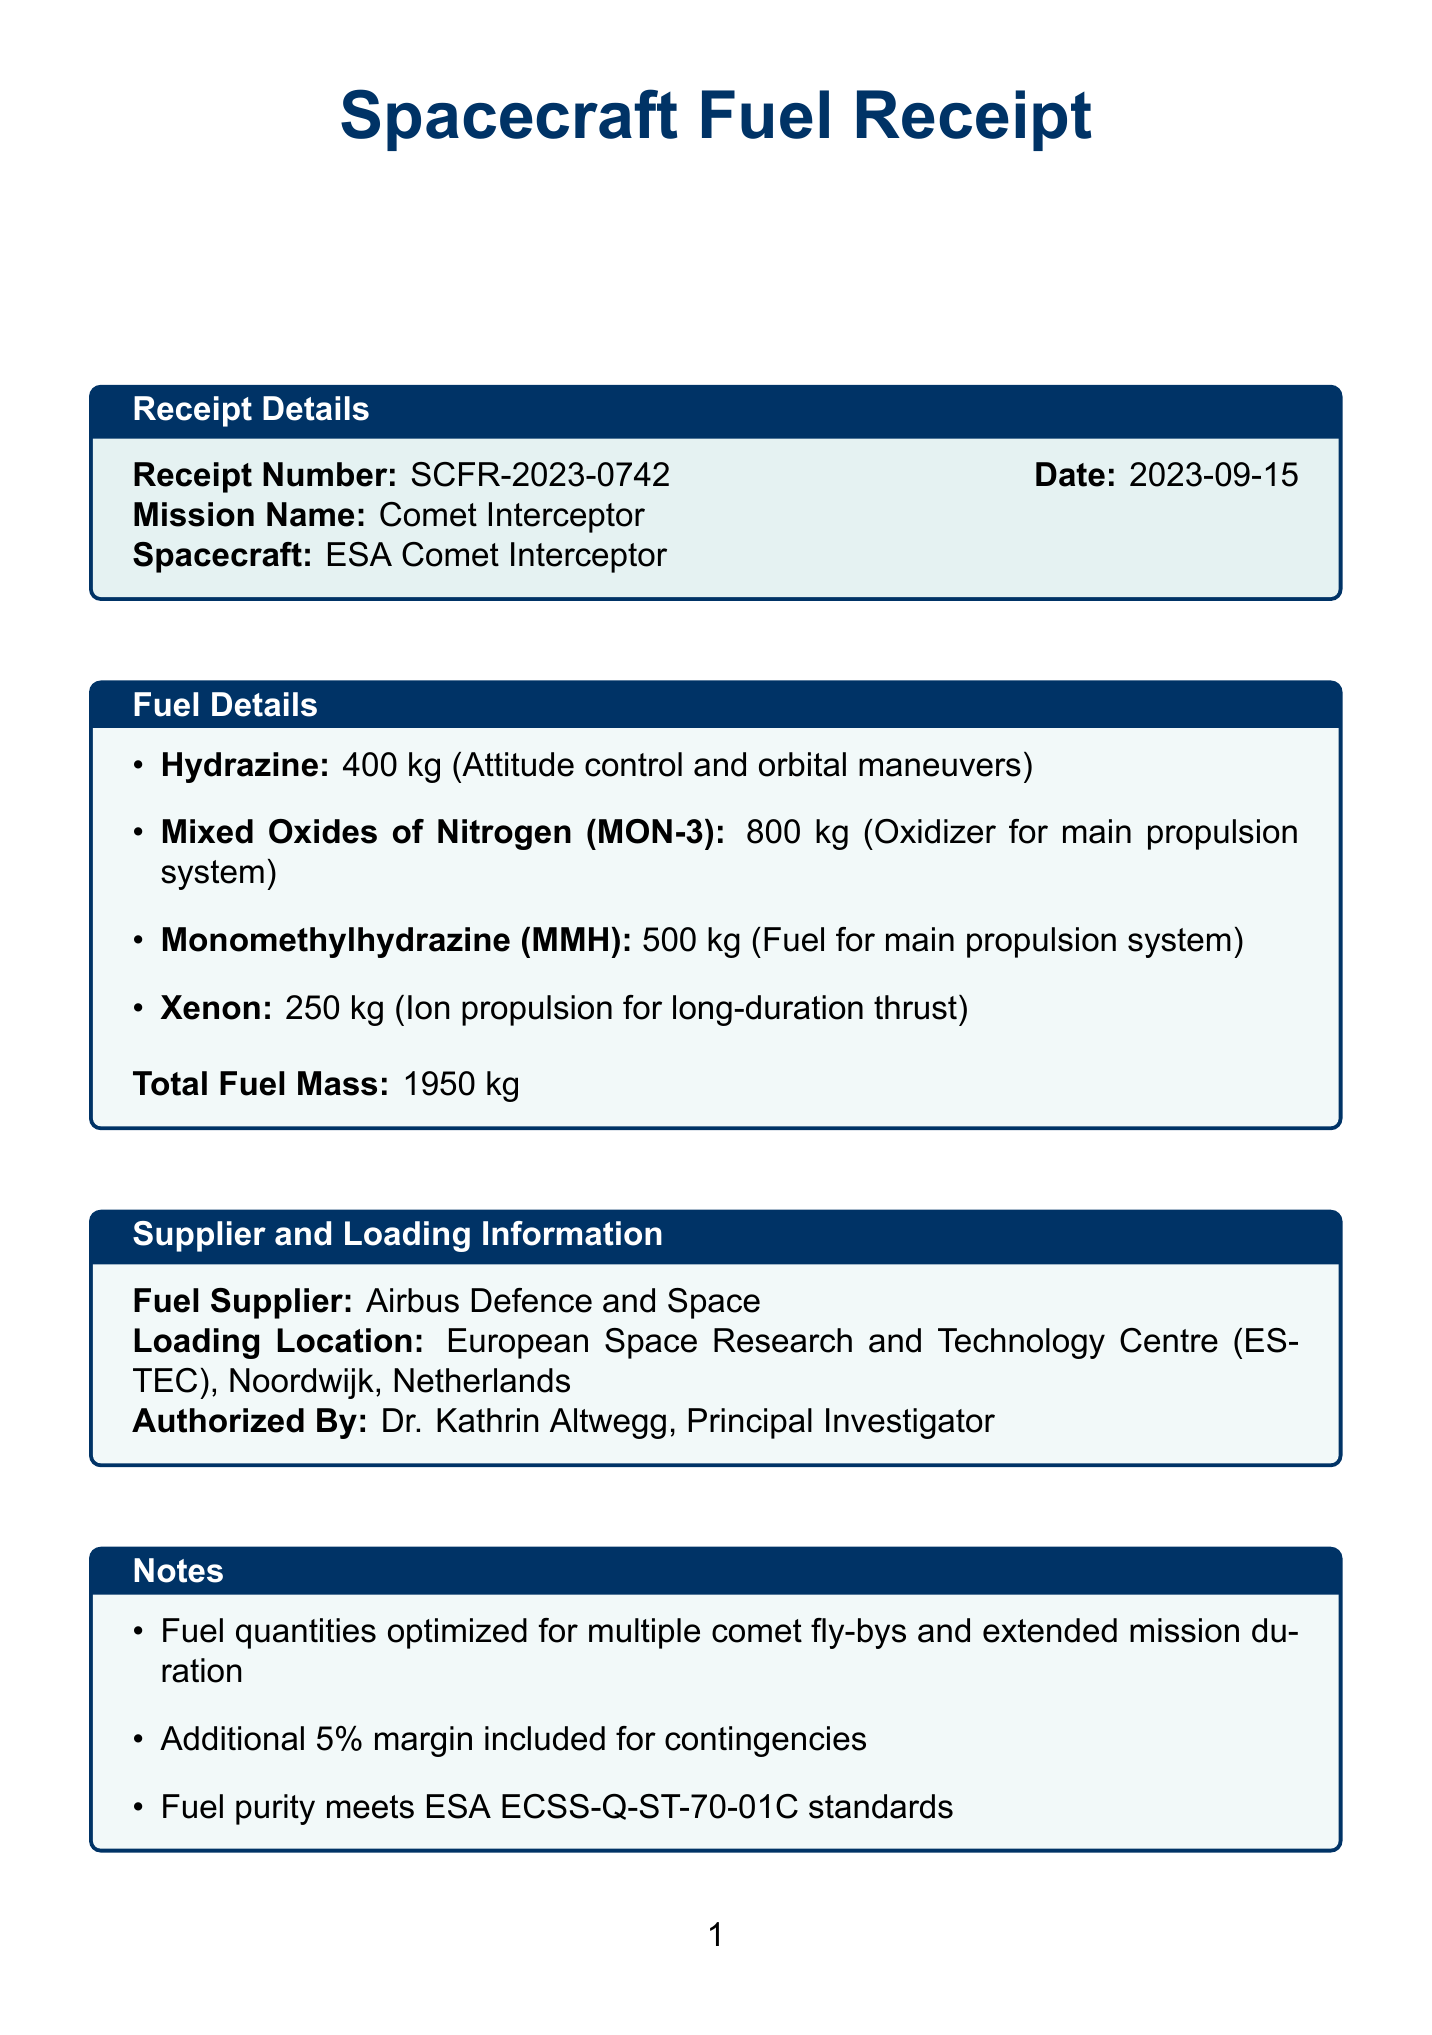What is the receipt number? The receipt number is provided in the document for reference, specifically "SCFR-2023-0742".
Answer: SCFR-2023-0742 What is the date of the receipt? The document indicates the date when the fuel was received, which is "2023-09-15".
Answer: 2023-09-15 How much Hydrazine is listed? The quantity of Hydrazine is specified in the fuel details section as "400 kg".
Answer: 400 kg Who authorized the fuel receipt? The document mentions "Dr. Kathrin Altwegg" as the person who authorized the fuel receipt.
Answer: Dr. Kathrin Altwegg What is the total fuel mass? The total mass of all fuels combined is indicated in the receipt as "1950 kg".
Answer: 1950 kg What type of fuel is used for long-duration thrust? The fuel specified for long-duration thrust in the document is "Xenon".
Answer: Xenon What safety procedure is required during fueling operations? The document specifies that "Personal Protective Equipment (PPE) required for all personnel during fueling operations" as part of the safety procedures.
Answer: PPE What is the mission name associated with this fuel receipt? The mission name referenced in the document is "Comet Interceptor".
Answer: Comet Interceptor Why were the fuel quantities optimized? The document notes that the fuel quantities were optimized "for multiple comet fly-bys and extended mission duration".
Answer: Multiple comet fly-bys and extended mission duration 